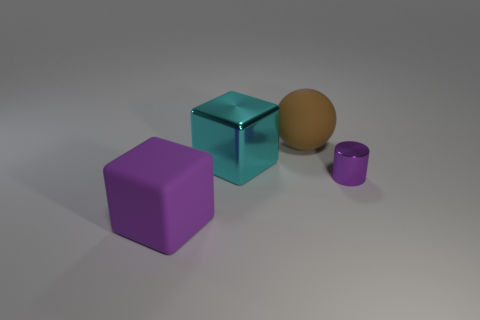How many big matte balls have the same color as the big rubber cube?
Ensure brevity in your answer.  0. What number of objects are big metal things or big rubber things on the left side of the brown object?
Your response must be concise. 2. The metal cylinder has what color?
Your answer should be compact. Purple. What color is the object that is behind the large shiny block?
Your answer should be compact. Brown. There is a big thing that is right of the big metal cube; what number of metallic cubes are on the right side of it?
Give a very brief answer. 0. Is the size of the cyan cube the same as the ball that is to the left of the small object?
Provide a succinct answer. Yes. Are there any blue shiny objects that have the same size as the matte block?
Keep it short and to the point. No. What number of things are cyan things or tiny rubber things?
Your response must be concise. 1. There is a cube behind the tiny purple shiny cylinder; is its size the same as the cube in front of the cylinder?
Your response must be concise. Yes. Is there a large cyan metal thing that has the same shape as the small purple object?
Your answer should be compact. No. 